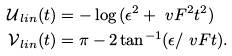<formula> <loc_0><loc_0><loc_500><loc_500>\mathcal { U } _ { \, l i n } ( t ) & = - \log { ( \epsilon ^ { 2 } + \ v F ^ { 2 } t ^ { 2 } ) } \\ \mathcal { V } _ { \, l i n } ( t ) & = \pi - 2 \tan ^ { - 1 } ( \epsilon / \ v F t ) .</formula> 